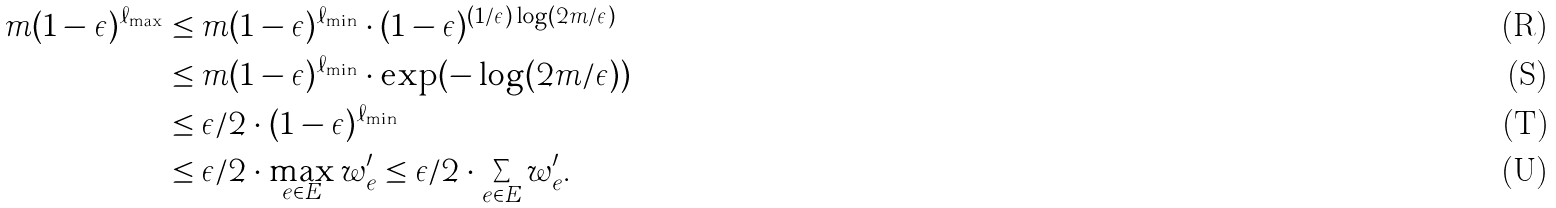<formula> <loc_0><loc_0><loc_500><loc_500>m ( 1 - \epsilon ) ^ { \ell _ { \max } } & \leq m ( 1 - \epsilon ) ^ { \ell _ { \min } } \cdot ( 1 - \epsilon ) ^ { ( 1 / \epsilon ) \log ( 2 m / \epsilon ) } \\ & \leq m ( 1 - \epsilon ) ^ { \ell _ { \min } } \cdot \exp ( - \log ( 2 m / \epsilon ) ) \\ & \leq \epsilon / 2 \cdot ( 1 - \epsilon ) ^ { \ell _ { \min } } \\ & \leq \epsilon / 2 \cdot \max _ { e \in E } w ^ { \prime } _ { e } \leq \epsilon / 2 \cdot \sum _ { e \in E } w ^ { \prime } _ { e } .</formula> 